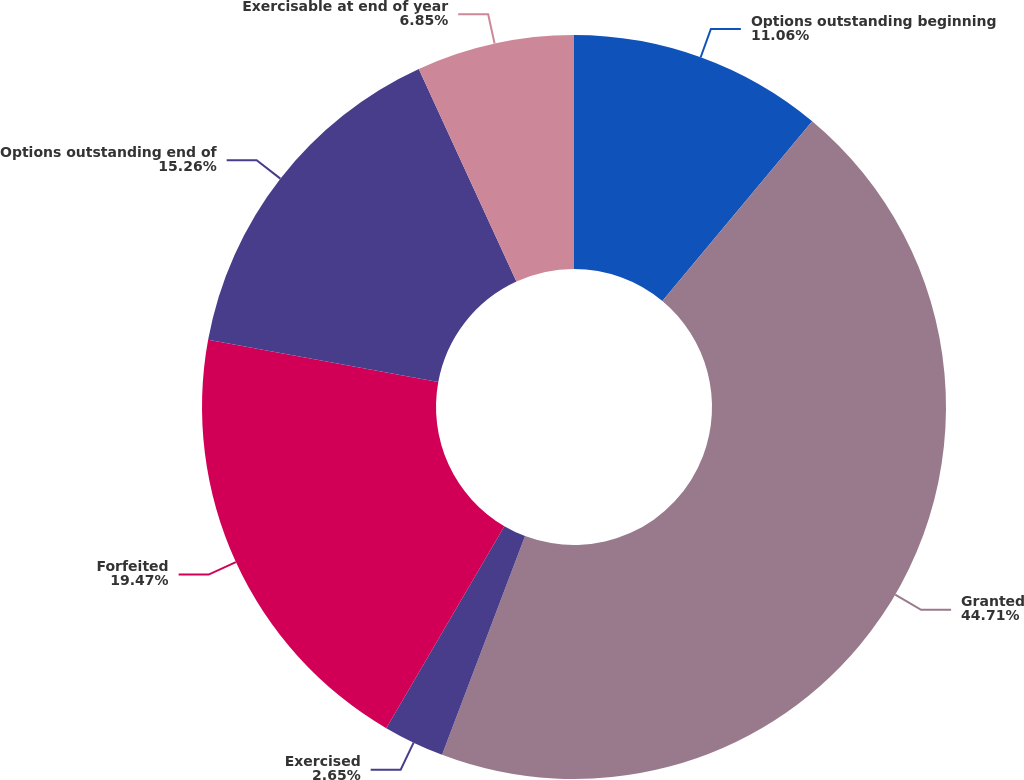Convert chart. <chart><loc_0><loc_0><loc_500><loc_500><pie_chart><fcel>Options outstanding beginning<fcel>Granted<fcel>Exercised<fcel>Forfeited<fcel>Options outstanding end of<fcel>Exercisable at end of year<nl><fcel>11.06%<fcel>44.71%<fcel>2.65%<fcel>19.47%<fcel>15.26%<fcel>6.85%<nl></chart> 